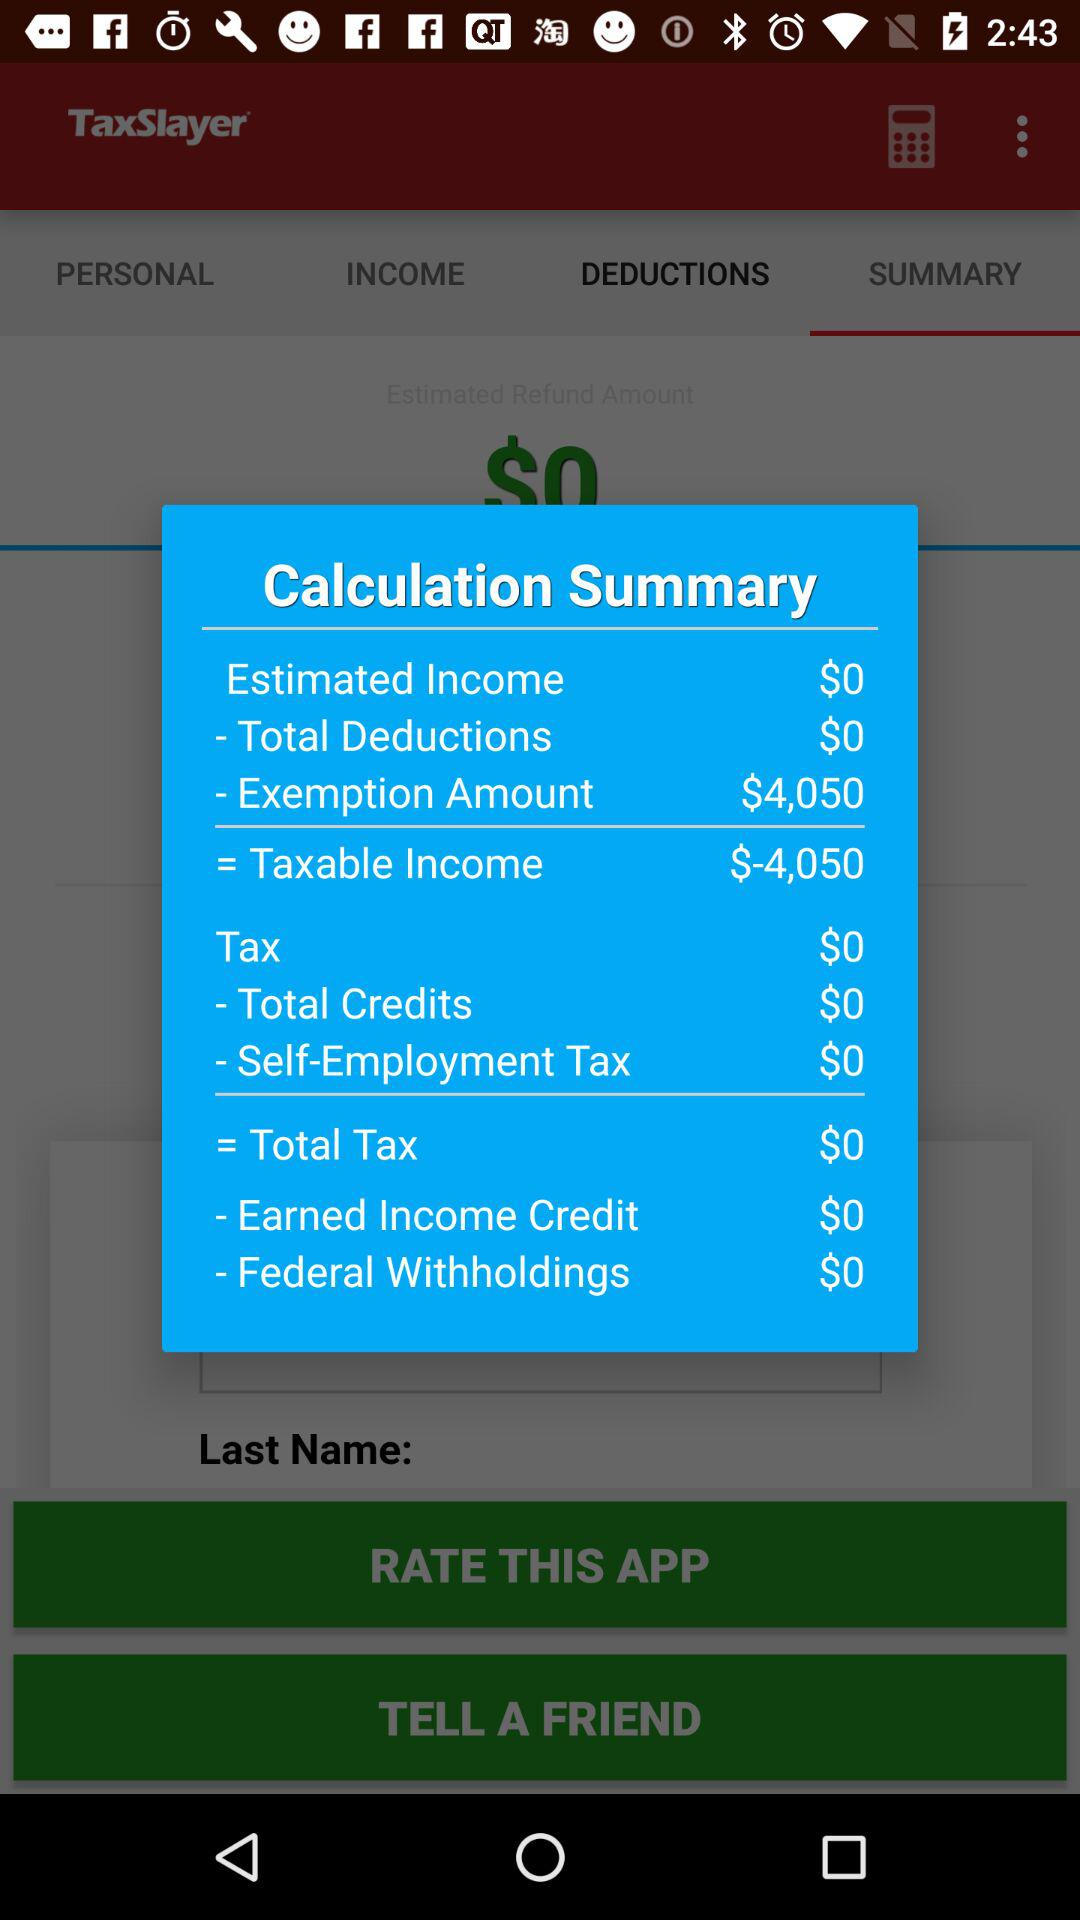What is the total amount of deductions?
Answer the question using a single word or phrase. $0 